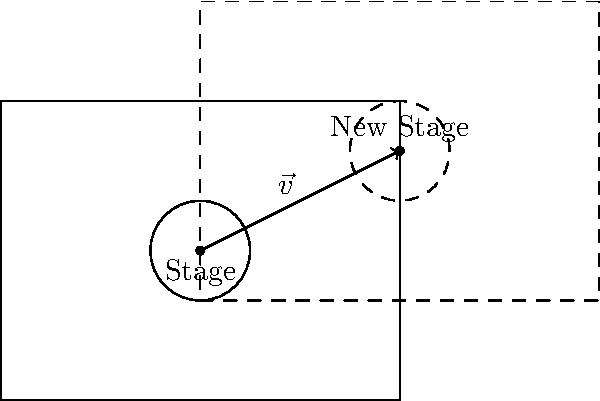As a comedy club regular, you've noticed the stage setup needs to be moved for tonight's guitar comedy act. The stage, represented by the rectangle ABCD with the circular performance area, needs to be translated by vector $\vec{v} = \langle 2, 1 \rangle$. What will be the coordinates of point C after the translation? To solve this problem, we'll follow these steps:

1) First, identify the initial coordinates of point C:
   C is at (4, 3) in the original setup.

2) Recall the translation formula:
   For any point (x, y) translated by vector $\vec{v} = \langle a, b \rangle$,
   the new coordinates are (x + a, y + b).

3) In this case, $\vec{v} = \langle 2, 1 \rangle$, so a = 2 and b = 1.

4) Apply the translation to point C(4, 3):
   New x-coordinate: 4 + 2 = 6
   New y-coordinate: 3 + 1 = 4

5) Therefore, after translation, point C will be at (6, 4).
Answer: (6, 4) 